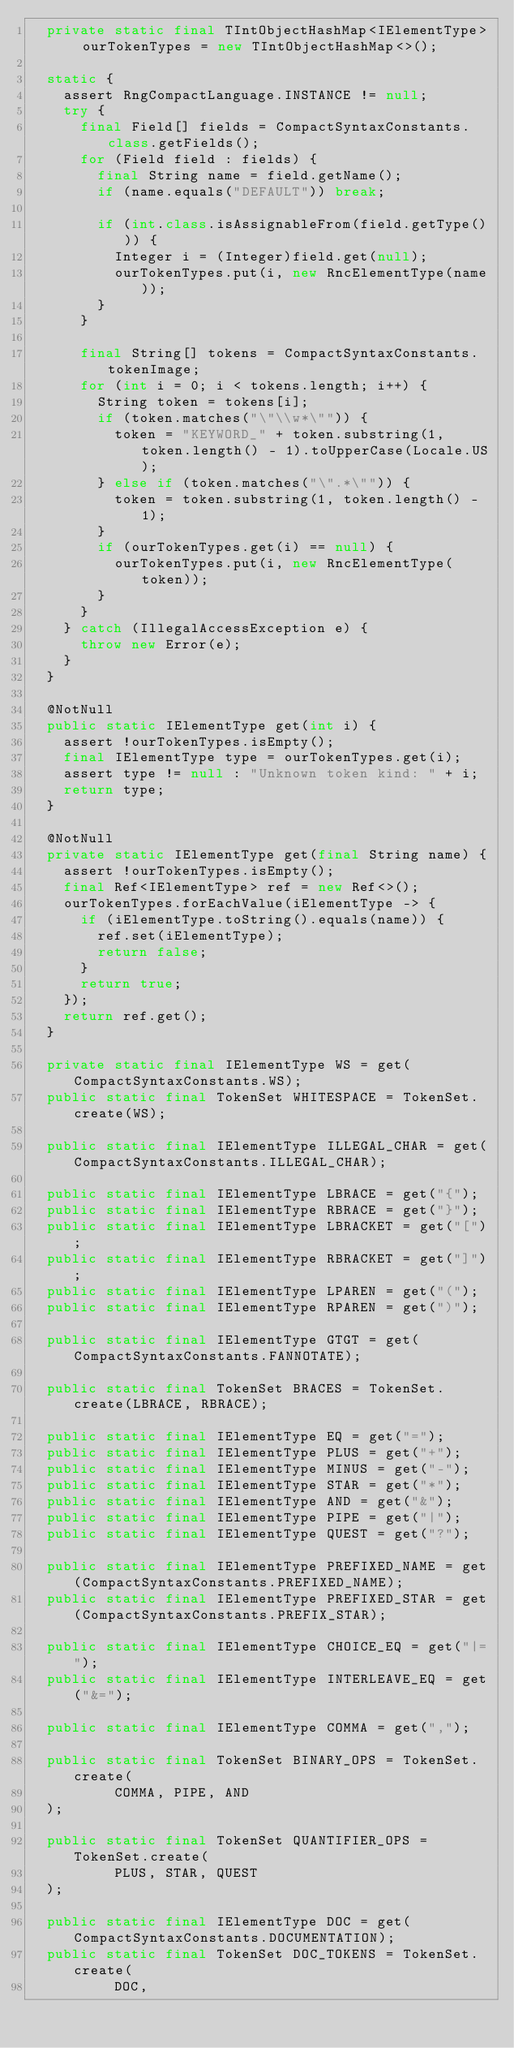<code> <loc_0><loc_0><loc_500><loc_500><_Java_>  private static final TIntObjectHashMap<IElementType> ourTokenTypes = new TIntObjectHashMap<>();

  static {
    assert RngCompactLanguage.INSTANCE != null;
    try {
      final Field[] fields = CompactSyntaxConstants.class.getFields();
      for (Field field : fields) {
        final String name = field.getName();
        if (name.equals("DEFAULT")) break;

        if (int.class.isAssignableFrom(field.getType())) {
          Integer i = (Integer)field.get(null);
          ourTokenTypes.put(i, new RncElementType(name));
        }
      }

      final String[] tokens = CompactSyntaxConstants.tokenImage;
      for (int i = 0; i < tokens.length; i++) {
        String token = tokens[i];
        if (token.matches("\"\\w*\"")) {
          token = "KEYWORD_" + token.substring(1, token.length() - 1).toUpperCase(Locale.US);
        } else if (token.matches("\".*\"")) {
          token = token.substring(1, token.length() - 1);
        }
        if (ourTokenTypes.get(i) == null) {
          ourTokenTypes.put(i, new RncElementType(token));
        }
      }
    } catch (IllegalAccessException e) {
      throw new Error(e);
    }
  }

  @NotNull
  public static IElementType get(int i) {
    assert !ourTokenTypes.isEmpty();
    final IElementType type = ourTokenTypes.get(i);
    assert type != null : "Unknown token kind: " + i;
    return type;
  }

  @NotNull
  private static IElementType get(final String name) {
    assert !ourTokenTypes.isEmpty();
    final Ref<IElementType> ref = new Ref<>();
    ourTokenTypes.forEachValue(iElementType -> {
      if (iElementType.toString().equals(name)) {
        ref.set(iElementType);
        return false;
      }
      return true;
    });
    return ref.get();
  }

  private static final IElementType WS = get(CompactSyntaxConstants.WS);
  public static final TokenSet WHITESPACE = TokenSet.create(WS);

  public static final IElementType ILLEGAL_CHAR = get(CompactSyntaxConstants.ILLEGAL_CHAR);
  
  public static final IElementType LBRACE = get("{");
  public static final IElementType RBRACE = get("}");
  public static final IElementType LBRACKET = get("[");
  public static final IElementType RBRACKET = get("]");
  public static final IElementType LPAREN = get("(");
  public static final IElementType RPAREN = get(")");

  public static final IElementType GTGT = get(CompactSyntaxConstants.FANNOTATE);

  public static final TokenSet BRACES = TokenSet.create(LBRACE, RBRACE);

  public static final IElementType EQ = get("=");
  public static final IElementType PLUS = get("+");
  public static final IElementType MINUS = get("-");
  public static final IElementType STAR = get("*");
  public static final IElementType AND = get("&");
  public static final IElementType PIPE = get("|");
  public static final IElementType QUEST = get("?");

  public static final IElementType PREFIXED_NAME = get(CompactSyntaxConstants.PREFIXED_NAME);
  public static final IElementType PREFIXED_STAR = get(CompactSyntaxConstants.PREFIX_STAR);

  public static final IElementType CHOICE_EQ = get("|=");
  public static final IElementType INTERLEAVE_EQ = get("&=");

  public static final IElementType COMMA = get(",");

  public static final TokenSet BINARY_OPS = TokenSet.create(
          COMMA, PIPE, AND
  );

  public static final TokenSet QUANTIFIER_OPS = TokenSet.create(
          PLUS, STAR, QUEST
  );

  public static final IElementType DOC = get(CompactSyntaxConstants.DOCUMENTATION);
  public static final TokenSet DOC_TOKENS = TokenSet.create(
          DOC,</code> 